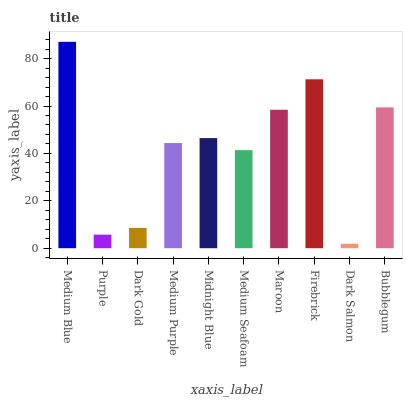Is Dark Salmon the minimum?
Answer yes or no. Yes. Is Medium Blue the maximum?
Answer yes or no. Yes. Is Purple the minimum?
Answer yes or no. No. Is Purple the maximum?
Answer yes or no. No. Is Medium Blue greater than Purple?
Answer yes or no. Yes. Is Purple less than Medium Blue?
Answer yes or no. Yes. Is Purple greater than Medium Blue?
Answer yes or no. No. Is Medium Blue less than Purple?
Answer yes or no. No. Is Midnight Blue the high median?
Answer yes or no. Yes. Is Medium Purple the low median?
Answer yes or no. Yes. Is Medium Purple the high median?
Answer yes or no. No. Is Firebrick the low median?
Answer yes or no. No. 